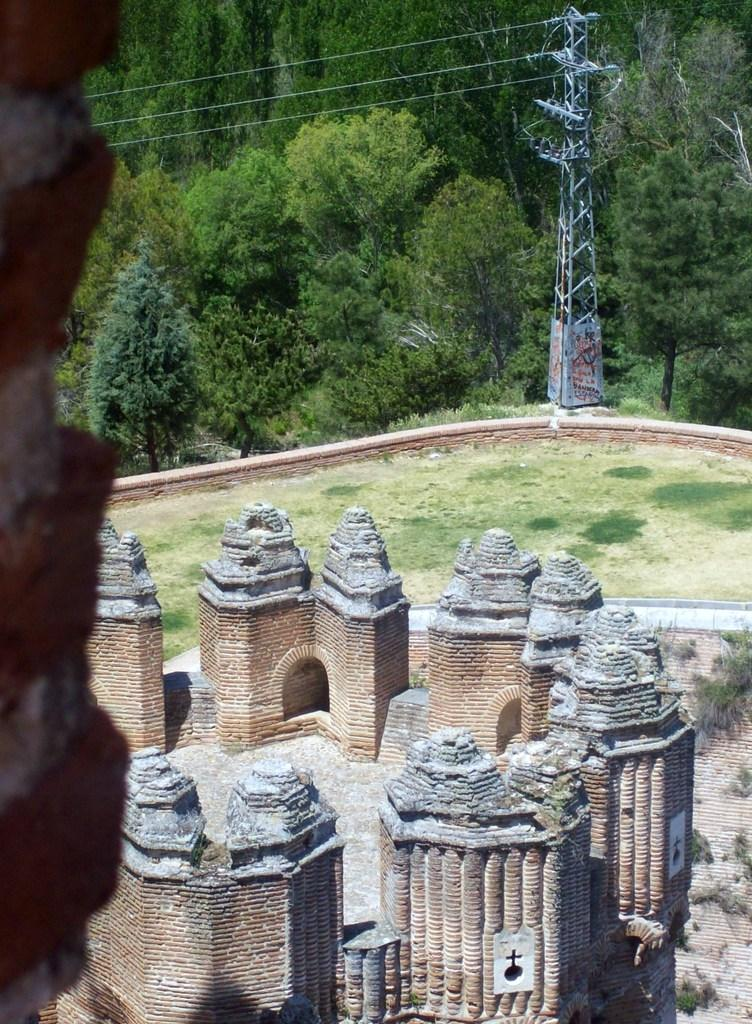What type of structures are on the ground in the image? There are pillars on the ground in the image. What type of natural environment is visible in the image? There is grass visible in the image. What is the tallest structure in the image? There is a tower in the image. What type of vegetation is present in the image? There are trees in the image. What type of boundary can be seen in the image? There is no boundary present in the image. What type of tail is visible on the tower in the image? There is no tail present on the tower in the image. 